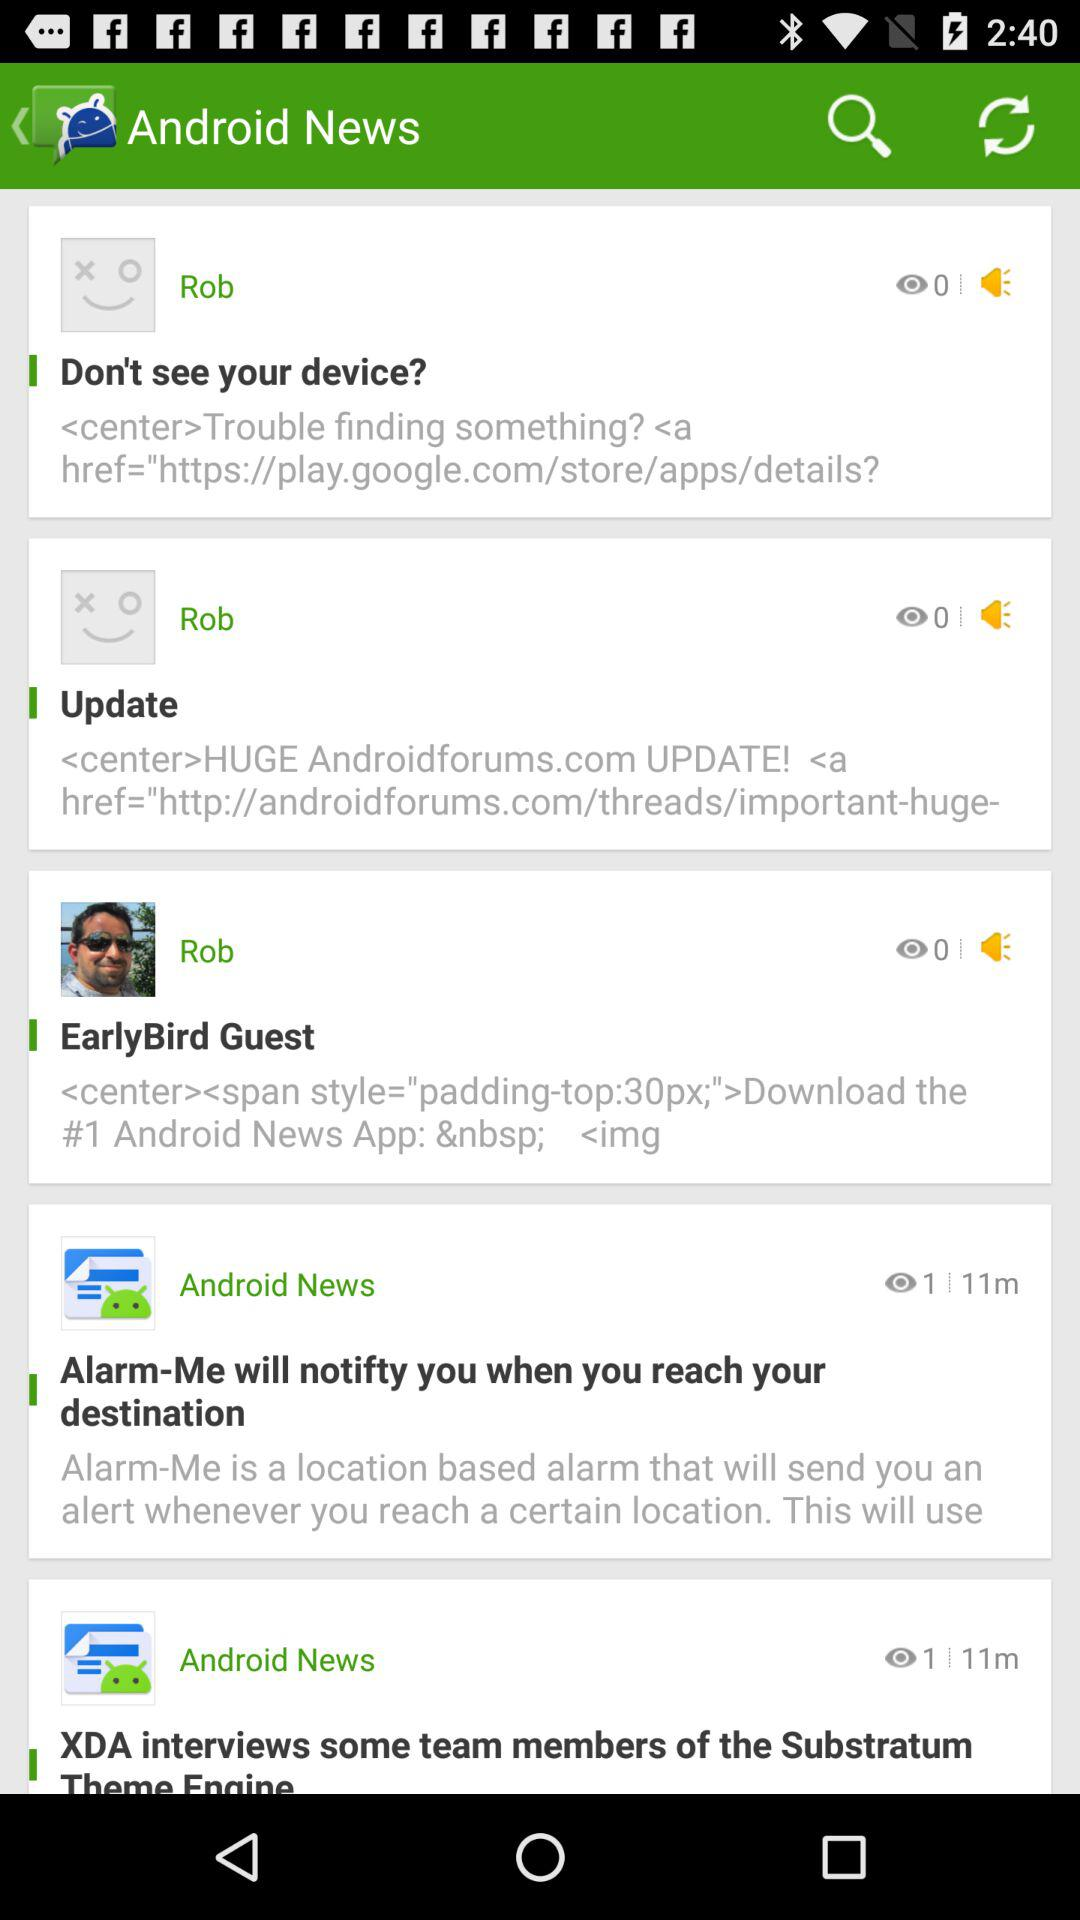Who posted the news? The news was posted by Rob. 